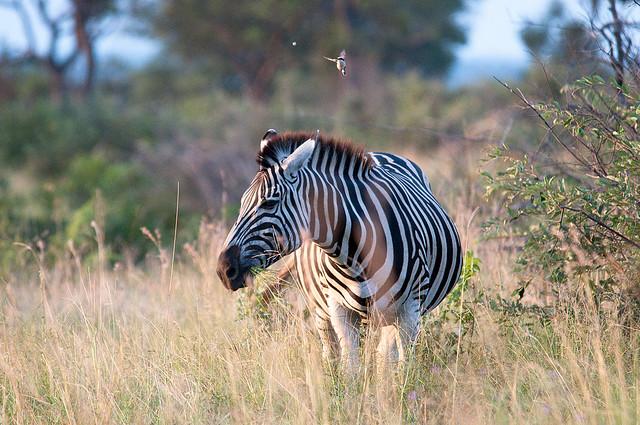Where is the zebra in the photo?
Write a very short answer. Middle. Is there a bird flying on top of the zebra?
Give a very brief answer. Yes. Is the grass taller than the zebra?
Quick response, please. No. 